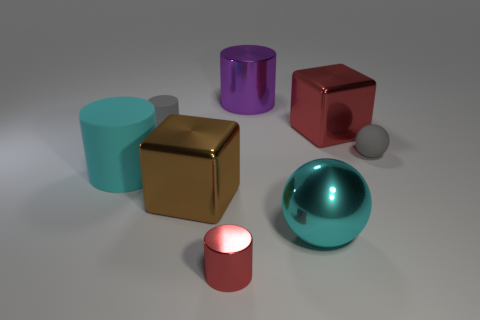There is a ball on the left side of the red shiny object that is behind the cyan matte cylinder; is there a tiny gray rubber cylinder in front of it?
Make the answer very short. No. What material is the ball that is in front of the big cyan cylinder?
Offer a very short reply. Metal. Do the big cyan rubber thing and the small gray thing that is to the left of the gray sphere have the same shape?
Your answer should be very brief. Yes. Is the number of large cyan metallic spheres that are behind the small rubber cylinder the same as the number of gray matte things that are to the left of the red cube?
Offer a very short reply. No. What number of other objects are there of the same material as the large cyan cylinder?
Your answer should be compact. 2. How many matte objects are either large red blocks or tiny blocks?
Offer a very short reply. 0. Is the shape of the small gray rubber object that is right of the small metallic thing the same as  the large cyan shiny thing?
Provide a succinct answer. Yes. Are there more large matte objects behind the red metallic cylinder than small green cylinders?
Provide a short and direct response. Yes. What number of red things are both behind the small sphere and left of the red metal cube?
Offer a very short reply. 0. What color is the tiny cylinder behind the big cube that is left of the red block?
Your response must be concise. Gray. 